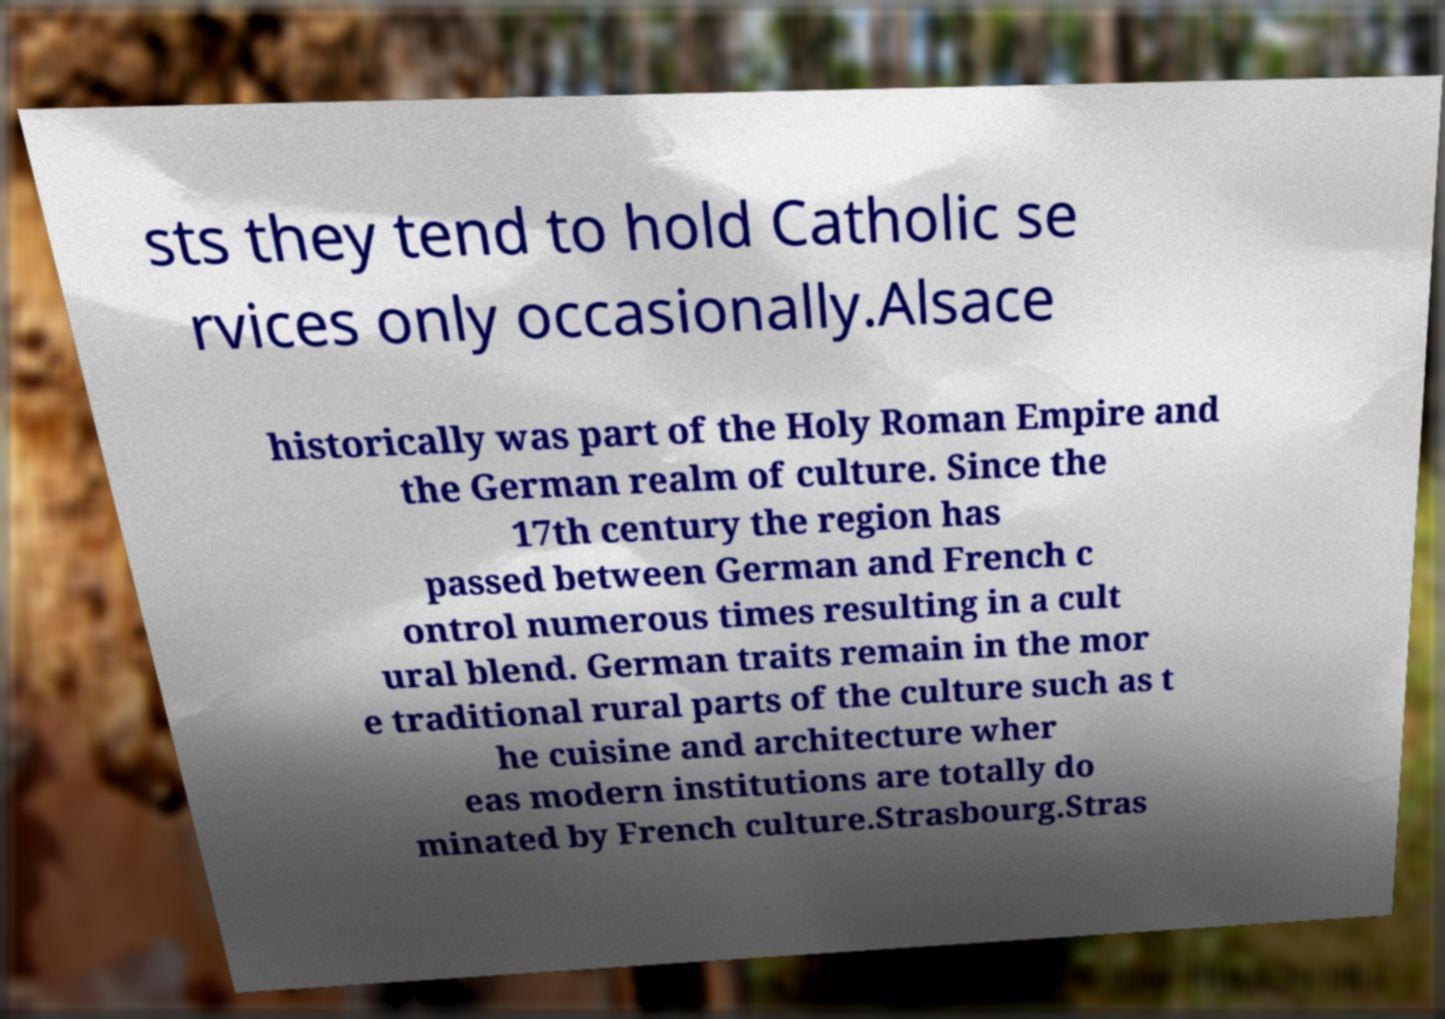For documentation purposes, I need the text within this image transcribed. Could you provide that? sts they tend to hold Catholic se rvices only occasionally.Alsace historically was part of the Holy Roman Empire and the German realm of culture. Since the 17th century the region has passed between German and French c ontrol numerous times resulting in a cult ural blend. German traits remain in the mor e traditional rural parts of the culture such as t he cuisine and architecture wher eas modern institutions are totally do minated by French culture.Strasbourg.Stras 